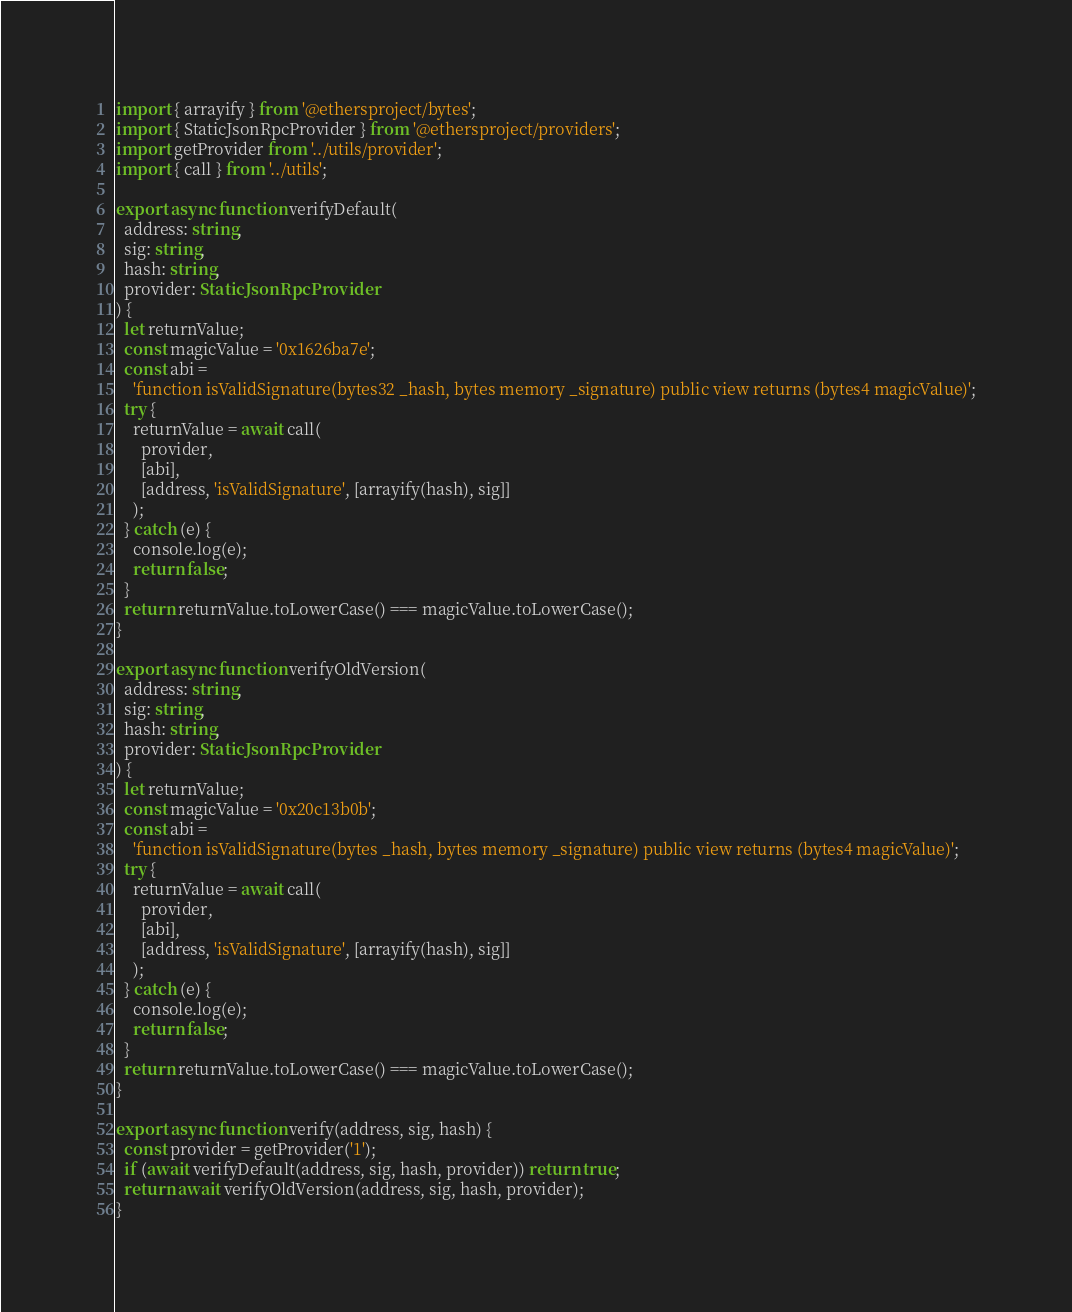Convert code to text. <code><loc_0><loc_0><loc_500><loc_500><_TypeScript_>import { arrayify } from '@ethersproject/bytes';
import { StaticJsonRpcProvider } from '@ethersproject/providers';
import getProvider from '../utils/provider';
import { call } from '../utils';

export async function verifyDefault(
  address: string,
  sig: string,
  hash: string,
  provider: StaticJsonRpcProvider
) {
  let returnValue;
  const magicValue = '0x1626ba7e';
  const abi =
    'function isValidSignature(bytes32 _hash, bytes memory _signature) public view returns (bytes4 magicValue)';
  try {
    returnValue = await call(
      provider,
      [abi],
      [address, 'isValidSignature', [arrayify(hash), sig]]
    );
  } catch (e) {
    console.log(e);
    return false;
  }
  return returnValue.toLowerCase() === magicValue.toLowerCase();
}

export async function verifyOldVersion(
  address: string,
  sig: string,
  hash: string,
  provider: StaticJsonRpcProvider
) {
  let returnValue;
  const magicValue = '0x20c13b0b';
  const abi =
    'function isValidSignature(bytes _hash, bytes memory _signature) public view returns (bytes4 magicValue)';
  try {
    returnValue = await call(
      provider,
      [abi],
      [address, 'isValidSignature', [arrayify(hash), sig]]
    );
  } catch (e) {
    console.log(e);
    return false;
  }
  return returnValue.toLowerCase() === magicValue.toLowerCase();
}

export async function verify(address, sig, hash) {
  const provider = getProvider('1');
  if (await verifyDefault(address, sig, hash, provider)) return true;
  return await verifyOldVersion(address, sig, hash, provider);
}
</code> 